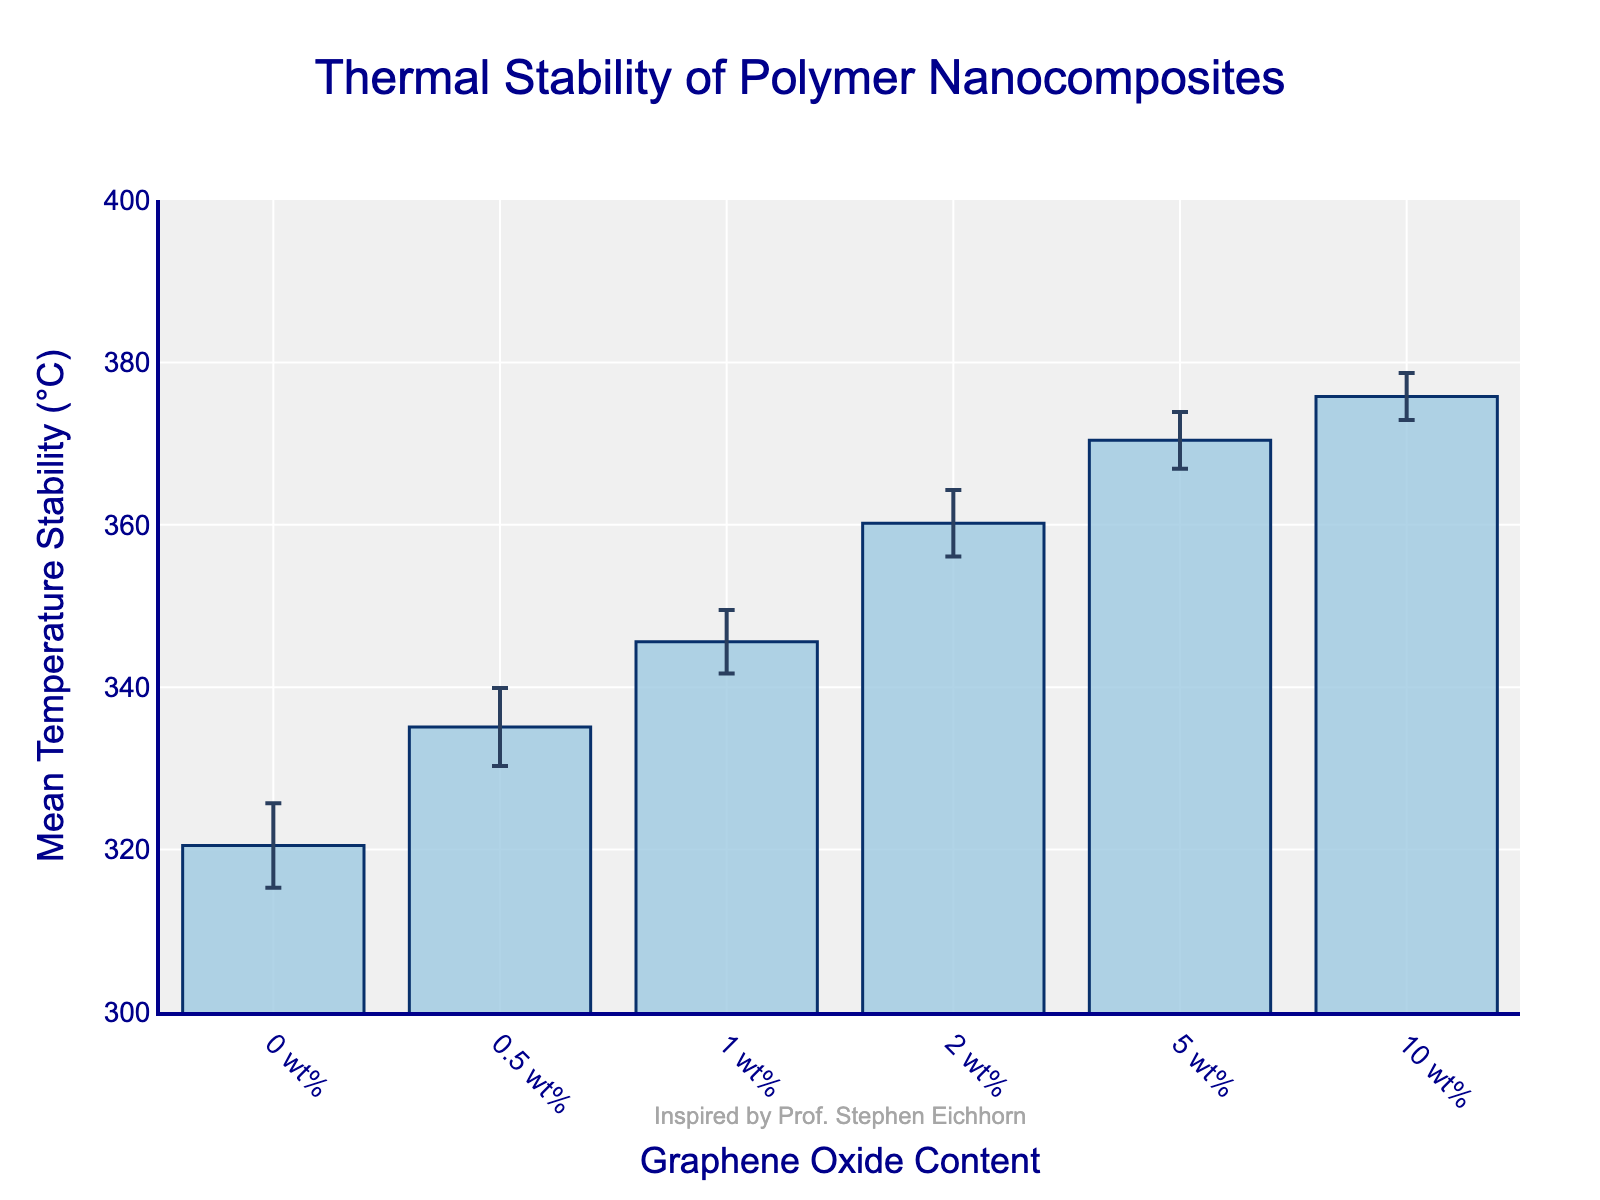What's the title of the plot? The title is displayed at the top of the plot in larger font size and a different color, making it easily noticeable.
Answer: Thermal Stability of Polymer Nanocomposites What is the x-axis label? The label for the x-axis is located below the axis itself, clearly indicating the variable represented by this axis.
Answer: Graphene Oxide Content What is the y-axis label? The label for the y-axis is situated along the left side of the plot, describing the variable plotted on this axis.
Answer: Mean Temperature Stability (°C) How many data points are presented in the figure? Each bar represents a different data point corresponding to a specific content of graphene oxide, making it straightforward to count them. There are six bars.
Answer: 6 Which graphene oxide content has the highest mean temperature stability? The highest bar in the plot indicates the graphene oxide content with the highest mean temperature stability. The bar for 10 wt% is the tallest.
Answer: 10 wt% What is the mean temperature stability for 5 wt% graphene oxide content? The height of the bar corresponding to 5 wt% on the x-axis shows the mean temperature stability value. The bar indicates a mean of 370.4°C.
Answer: 370.4°C How does the mean temperature stability change as the graphene oxide content increases from 0 wt% to 10 wt%? Observing the height of the bars from left to right (0 wt% to 10 wt%), we see an increase, indicating that the mean temperature stability rises with increasing graphene oxide content.
Answer: It increases What is the difference in mean temperature stability between 0.5 wt% and 2 wt% graphene oxide content? Subtract the mean value for 0.5 wt% from the mean value for 2 wt% (335.1°C - 360.2°C).
Answer: 25.1°C Which data point has the smallest error bar, and what does it signify? The shortest error bar indicates the data point with the least variability or uncertainty. The bar for 10 wt% graphene oxide has the smallest error bar.
Answer: 10 wt%; smallest variability What is the overall trend observed in the error bars as the graphene oxide content increases? Observing the lengths of the error bars from left to right, we notice they generally decrease.
Answer: Error bars decrease 